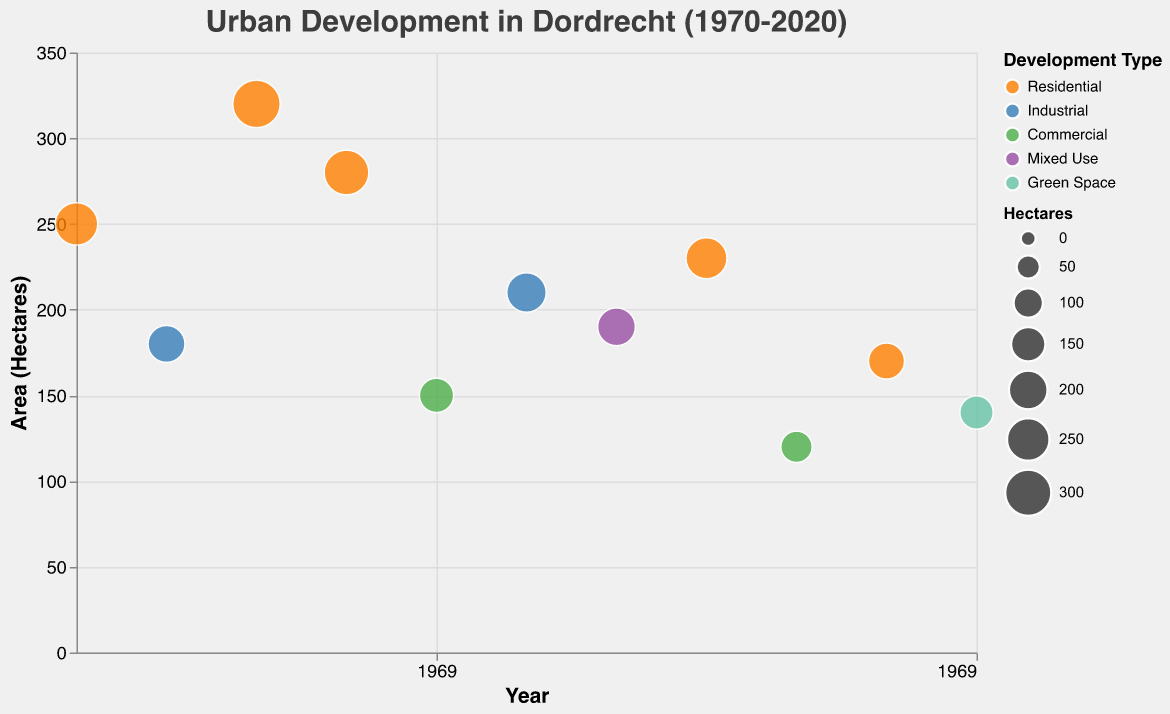What is the title of the figure? The title of the figure is displayed at the top of the chart.
Answer: Urban Development in Dordrecht (1970-2020) How many areas were developed for industrial use according to the figure? By looking at the color legend and the data points, two areas are represented with the color for Industrial use.
Answer: 2 Which area had the largest development in hectares? By looking at the sizes of the circles, the area with the largest circle represents the largest hectares, which corresponds to Sterrenburg in 1980.
Answer: Sterrenburg (320 hectares) When was the De Staart area developed, and what type of development was it? The tooltip for the De Staart area shows the year 2000 and indicates a Mixed Use development type.
Answer: 2000, Mixed Use How many residential areas were developed, and what is their combined area in hectares? There are five areas marked as Residential, and their combined area is the sum of their hectares: 250 + 320 + 280 + 230 + 170 = 1250 hectares.
Answer: 5 areas, 1250 hectares Which year saw the smallest development in hectares, and what type was it? By looking at the smallest circle, the tooltip reveals that it corresponds to Reeland in 2010 with 120 hectares, which is Commercial.
Answer: 2010, Commercial Arrange the development types in order of the number of hectares developed, starting with the most. Adding up the hectares for each type: 
Residential (250 + 320 + 280 + 230 + 170 = 1250), 
Industrial (180 + 210 = 390), 
Commercial (150 + 120 = 270), 
Mixed Use (190), 
Green Space (140). 
The order is Residential, Industrial, Commercial, Mixed Use, Green Space.
Answer: Residential, Industrial, Commercial, Mixed Use, Green Space Between 2000 and 2020, how many different types of development occurred? Checking the data points between 2000 and 2020, three distinct types of development are labeled: Mixed Use (2000), Commercial (2010), and Green Space (2020).
Answer: 3 Is there a trend in the type of development over the years? Examining the development types and their corresponding years, it can be seen that there is a general shift from Residential and Industrial in the early years to varied types such as Mixed Use, Commercial, and Green Space in later years.
Answer: Shift from Residential and Industrial to varied types Which areas were developed for commercial use, and in what years? The areas with Commercial use as indicated by the legend and tooltips are Amstelwijck (1990) and Reeland (2010).
Answer: Amstelwijck (1990), Reeland (2010) 